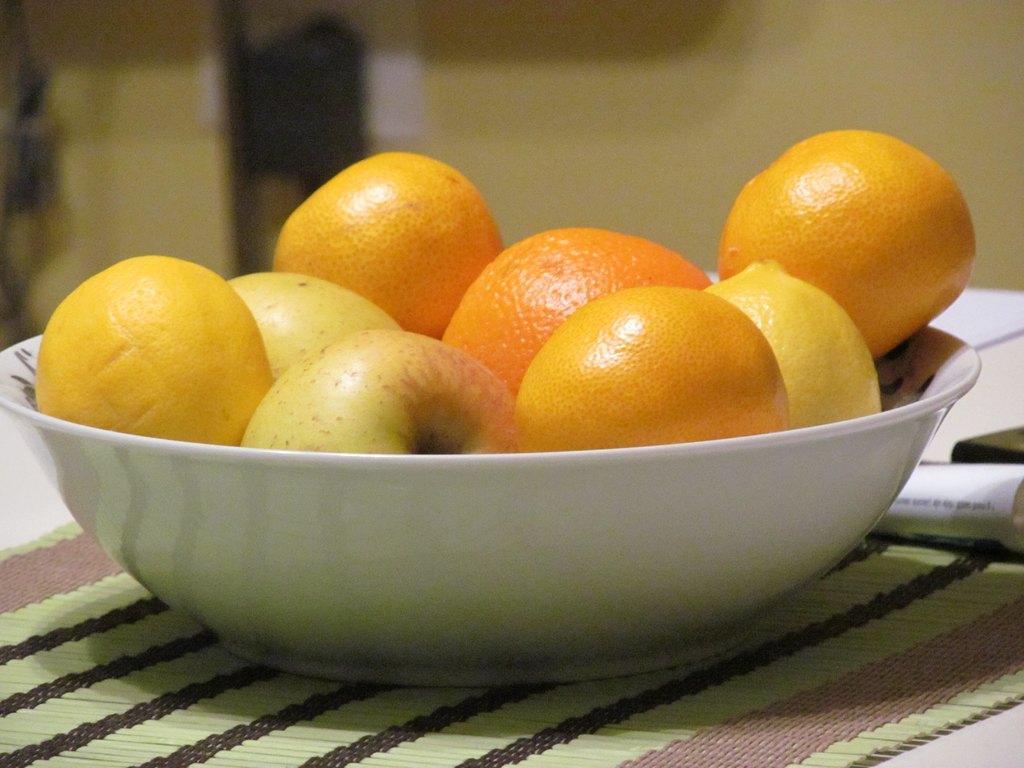Can you describe this image briefly? In this picture we can see few fruits in the bowl, on the right side of the image we can find a paper and we can see blurry background. 